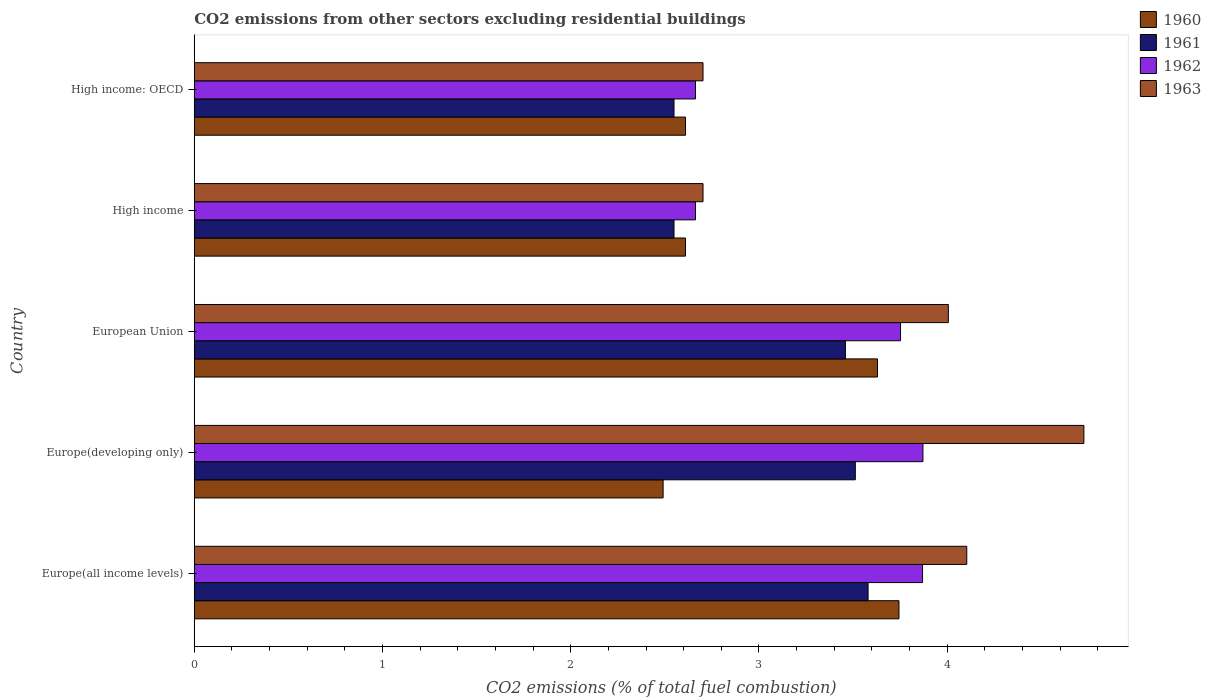Are the number of bars per tick equal to the number of legend labels?
Your answer should be compact. Yes. How many bars are there on the 2nd tick from the bottom?
Offer a terse response. 4. What is the label of the 5th group of bars from the top?
Your answer should be very brief. Europe(all income levels). In how many cases, is the number of bars for a given country not equal to the number of legend labels?
Keep it short and to the point. 0. What is the total CO2 emitted in 1963 in Europe(developing only)?
Your answer should be compact. 4.73. Across all countries, what is the maximum total CO2 emitted in 1960?
Ensure brevity in your answer.  3.74. Across all countries, what is the minimum total CO2 emitted in 1960?
Offer a terse response. 2.49. In which country was the total CO2 emitted in 1960 maximum?
Provide a succinct answer. Europe(all income levels). In which country was the total CO2 emitted in 1960 minimum?
Make the answer very short. Europe(developing only). What is the total total CO2 emitted in 1961 in the graph?
Give a very brief answer. 15.65. What is the difference between the total CO2 emitted in 1963 in European Union and that in High income: OECD?
Offer a terse response. 1.3. What is the difference between the total CO2 emitted in 1960 in High income and the total CO2 emitted in 1963 in High income: OECD?
Provide a succinct answer. -0.09. What is the average total CO2 emitted in 1961 per country?
Offer a terse response. 3.13. What is the difference between the total CO2 emitted in 1961 and total CO2 emitted in 1963 in European Union?
Provide a short and direct response. -0.55. In how many countries, is the total CO2 emitted in 1963 greater than 4.2 ?
Your answer should be compact. 1. What is the ratio of the total CO2 emitted in 1961 in Europe(developing only) to that in High income?
Ensure brevity in your answer.  1.38. What is the difference between the highest and the second highest total CO2 emitted in 1963?
Ensure brevity in your answer.  0.62. What is the difference between the highest and the lowest total CO2 emitted in 1962?
Your answer should be compact. 1.21. Is the sum of the total CO2 emitted in 1963 in Europe(all income levels) and High income greater than the maximum total CO2 emitted in 1960 across all countries?
Offer a very short reply. Yes. Is it the case that in every country, the sum of the total CO2 emitted in 1963 and total CO2 emitted in 1960 is greater than the sum of total CO2 emitted in 1961 and total CO2 emitted in 1962?
Ensure brevity in your answer.  No. What does the 3rd bar from the top in High income: OECD represents?
Keep it short and to the point. 1961. How many bars are there?
Provide a succinct answer. 20. How many countries are there in the graph?
Make the answer very short. 5. What is the difference between two consecutive major ticks on the X-axis?
Keep it short and to the point. 1. Does the graph contain any zero values?
Your response must be concise. No. Does the graph contain grids?
Provide a short and direct response. No. Where does the legend appear in the graph?
Provide a short and direct response. Top right. How many legend labels are there?
Give a very brief answer. 4. What is the title of the graph?
Your answer should be compact. CO2 emissions from other sectors excluding residential buildings. What is the label or title of the X-axis?
Offer a terse response. CO2 emissions (% of total fuel combustion). What is the label or title of the Y-axis?
Keep it short and to the point. Country. What is the CO2 emissions (% of total fuel combustion) in 1960 in Europe(all income levels)?
Ensure brevity in your answer.  3.74. What is the CO2 emissions (% of total fuel combustion) in 1961 in Europe(all income levels)?
Offer a very short reply. 3.58. What is the CO2 emissions (% of total fuel combustion) in 1962 in Europe(all income levels)?
Provide a short and direct response. 3.87. What is the CO2 emissions (% of total fuel combustion) of 1963 in Europe(all income levels)?
Your answer should be compact. 4.1. What is the CO2 emissions (% of total fuel combustion) of 1960 in Europe(developing only)?
Your answer should be very brief. 2.49. What is the CO2 emissions (% of total fuel combustion) in 1961 in Europe(developing only)?
Provide a succinct answer. 3.51. What is the CO2 emissions (% of total fuel combustion) of 1962 in Europe(developing only)?
Your answer should be very brief. 3.87. What is the CO2 emissions (% of total fuel combustion) in 1963 in Europe(developing only)?
Provide a succinct answer. 4.73. What is the CO2 emissions (% of total fuel combustion) of 1960 in European Union?
Keep it short and to the point. 3.63. What is the CO2 emissions (% of total fuel combustion) of 1961 in European Union?
Give a very brief answer. 3.46. What is the CO2 emissions (% of total fuel combustion) of 1962 in European Union?
Your answer should be very brief. 3.75. What is the CO2 emissions (% of total fuel combustion) in 1963 in European Union?
Make the answer very short. 4.01. What is the CO2 emissions (% of total fuel combustion) in 1960 in High income?
Your answer should be compact. 2.61. What is the CO2 emissions (% of total fuel combustion) in 1961 in High income?
Your response must be concise. 2.55. What is the CO2 emissions (% of total fuel combustion) in 1962 in High income?
Your answer should be compact. 2.66. What is the CO2 emissions (% of total fuel combustion) in 1963 in High income?
Provide a succinct answer. 2.7. What is the CO2 emissions (% of total fuel combustion) in 1960 in High income: OECD?
Your answer should be compact. 2.61. What is the CO2 emissions (% of total fuel combustion) of 1961 in High income: OECD?
Provide a short and direct response. 2.55. What is the CO2 emissions (% of total fuel combustion) in 1962 in High income: OECD?
Your answer should be compact. 2.66. What is the CO2 emissions (% of total fuel combustion) in 1963 in High income: OECD?
Offer a terse response. 2.7. Across all countries, what is the maximum CO2 emissions (% of total fuel combustion) of 1960?
Give a very brief answer. 3.74. Across all countries, what is the maximum CO2 emissions (% of total fuel combustion) of 1961?
Make the answer very short. 3.58. Across all countries, what is the maximum CO2 emissions (% of total fuel combustion) of 1962?
Your answer should be very brief. 3.87. Across all countries, what is the maximum CO2 emissions (% of total fuel combustion) of 1963?
Give a very brief answer. 4.73. Across all countries, what is the minimum CO2 emissions (% of total fuel combustion) in 1960?
Keep it short and to the point. 2.49. Across all countries, what is the minimum CO2 emissions (% of total fuel combustion) in 1961?
Ensure brevity in your answer.  2.55. Across all countries, what is the minimum CO2 emissions (% of total fuel combustion) in 1962?
Provide a short and direct response. 2.66. Across all countries, what is the minimum CO2 emissions (% of total fuel combustion) in 1963?
Ensure brevity in your answer.  2.7. What is the total CO2 emissions (% of total fuel combustion) of 1960 in the graph?
Provide a short and direct response. 15.08. What is the total CO2 emissions (% of total fuel combustion) of 1961 in the graph?
Ensure brevity in your answer.  15.65. What is the total CO2 emissions (% of total fuel combustion) in 1962 in the graph?
Your answer should be very brief. 16.82. What is the total CO2 emissions (% of total fuel combustion) of 1963 in the graph?
Make the answer very short. 18.24. What is the difference between the CO2 emissions (% of total fuel combustion) of 1960 in Europe(all income levels) and that in Europe(developing only)?
Make the answer very short. 1.25. What is the difference between the CO2 emissions (% of total fuel combustion) of 1961 in Europe(all income levels) and that in Europe(developing only)?
Your response must be concise. 0.07. What is the difference between the CO2 emissions (% of total fuel combustion) of 1962 in Europe(all income levels) and that in Europe(developing only)?
Provide a short and direct response. -0. What is the difference between the CO2 emissions (% of total fuel combustion) of 1963 in Europe(all income levels) and that in Europe(developing only)?
Your answer should be very brief. -0.62. What is the difference between the CO2 emissions (% of total fuel combustion) in 1960 in Europe(all income levels) and that in European Union?
Provide a short and direct response. 0.11. What is the difference between the CO2 emissions (% of total fuel combustion) in 1961 in Europe(all income levels) and that in European Union?
Your answer should be compact. 0.12. What is the difference between the CO2 emissions (% of total fuel combustion) of 1962 in Europe(all income levels) and that in European Union?
Offer a terse response. 0.12. What is the difference between the CO2 emissions (% of total fuel combustion) in 1963 in Europe(all income levels) and that in European Union?
Keep it short and to the point. 0.1. What is the difference between the CO2 emissions (% of total fuel combustion) in 1960 in Europe(all income levels) and that in High income?
Your response must be concise. 1.13. What is the difference between the CO2 emissions (% of total fuel combustion) in 1961 in Europe(all income levels) and that in High income?
Offer a very short reply. 1.03. What is the difference between the CO2 emissions (% of total fuel combustion) in 1962 in Europe(all income levels) and that in High income?
Offer a very short reply. 1.21. What is the difference between the CO2 emissions (% of total fuel combustion) in 1963 in Europe(all income levels) and that in High income?
Provide a short and direct response. 1.4. What is the difference between the CO2 emissions (% of total fuel combustion) of 1960 in Europe(all income levels) and that in High income: OECD?
Your answer should be compact. 1.13. What is the difference between the CO2 emissions (% of total fuel combustion) in 1961 in Europe(all income levels) and that in High income: OECD?
Offer a terse response. 1.03. What is the difference between the CO2 emissions (% of total fuel combustion) of 1962 in Europe(all income levels) and that in High income: OECD?
Offer a terse response. 1.21. What is the difference between the CO2 emissions (% of total fuel combustion) in 1963 in Europe(all income levels) and that in High income: OECD?
Your response must be concise. 1.4. What is the difference between the CO2 emissions (% of total fuel combustion) in 1960 in Europe(developing only) and that in European Union?
Your answer should be very brief. -1.14. What is the difference between the CO2 emissions (% of total fuel combustion) in 1961 in Europe(developing only) and that in European Union?
Provide a succinct answer. 0.05. What is the difference between the CO2 emissions (% of total fuel combustion) of 1962 in Europe(developing only) and that in European Union?
Provide a short and direct response. 0.12. What is the difference between the CO2 emissions (% of total fuel combustion) in 1963 in Europe(developing only) and that in European Union?
Your answer should be very brief. 0.72. What is the difference between the CO2 emissions (% of total fuel combustion) in 1960 in Europe(developing only) and that in High income?
Your response must be concise. -0.12. What is the difference between the CO2 emissions (% of total fuel combustion) of 1961 in Europe(developing only) and that in High income?
Ensure brevity in your answer.  0.96. What is the difference between the CO2 emissions (% of total fuel combustion) of 1962 in Europe(developing only) and that in High income?
Provide a short and direct response. 1.21. What is the difference between the CO2 emissions (% of total fuel combustion) in 1963 in Europe(developing only) and that in High income?
Your answer should be compact. 2.02. What is the difference between the CO2 emissions (% of total fuel combustion) of 1960 in Europe(developing only) and that in High income: OECD?
Provide a short and direct response. -0.12. What is the difference between the CO2 emissions (% of total fuel combustion) of 1961 in Europe(developing only) and that in High income: OECD?
Provide a short and direct response. 0.96. What is the difference between the CO2 emissions (% of total fuel combustion) of 1962 in Europe(developing only) and that in High income: OECD?
Offer a very short reply. 1.21. What is the difference between the CO2 emissions (% of total fuel combustion) of 1963 in Europe(developing only) and that in High income: OECD?
Make the answer very short. 2.02. What is the difference between the CO2 emissions (% of total fuel combustion) of 1961 in European Union and that in High income?
Ensure brevity in your answer.  0.91. What is the difference between the CO2 emissions (% of total fuel combustion) in 1962 in European Union and that in High income?
Keep it short and to the point. 1.09. What is the difference between the CO2 emissions (% of total fuel combustion) of 1963 in European Union and that in High income?
Make the answer very short. 1.3. What is the difference between the CO2 emissions (% of total fuel combustion) of 1960 in European Union and that in High income: OECD?
Offer a terse response. 1.02. What is the difference between the CO2 emissions (% of total fuel combustion) of 1961 in European Union and that in High income: OECD?
Ensure brevity in your answer.  0.91. What is the difference between the CO2 emissions (% of total fuel combustion) of 1962 in European Union and that in High income: OECD?
Your answer should be very brief. 1.09. What is the difference between the CO2 emissions (% of total fuel combustion) of 1963 in European Union and that in High income: OECD?
Provide a short and direct response. 1.3. What is the difference between the CO2 emissions (% of total fuel combustion) in 1961 in High income and that in High income: OECD?
Offer a terse response. 0. What is the difference between the CO2 emissions (% of total fuel combustion) of 1963 in High income and that in High income: OECD?
Provide a short and direct response. 0. What is the difference between the CO2 emissions (% of total fuel combustion) in 1960 in Europe(all income levels) and the CO2 emissions (% of total fuel combustion) in 1961 in Europe(developing only)?
Offer a terse response. 0.23. What is the difference between the CO2 emissions (% of total fuel combustion) in 1960 in Europe(all income levels) and the CO2 emissions (% of total fuel combustion) in 1962 in Europe(developing only)?
Your answer should be compact. -0.13. What is the difference between the CO2 emissions (% of total fuel combustion) of 1960 in Europe(all income levels) and the CO2 emissions (% of total fuel combustion) of 1963 in Europe(developing only)?
Give a very brief answer. -0.98. What is the difference between the CO2 emissions (% of total fuel combustion) of 1961 in Europe(all income levels) and the CO2 emissions (% of total fuel combustion) of 1962 in Europe(developing only)?
Keep it short and to the point. -0.29. What is the difference between the CO2 emissions (% of total fuel combustion) in 1961 in Europe(all income levels) and the CO2 emissions (% of total fuel combustion) in 1963 in Europe(developing only)?
Provide a short and direct response. -1.15. What is the difference between the CO2 emissions (% of total fuel combustion) of 1962 in Europe(all income levels) and the CO2 emissions (% of total fuel combustion) of 1963 in Europe(developing only)?
Your response must be concise. -0.86. What is the difference between the CO2 emissions (% of total fuel combustion) in 1960 in Europe(all income levels) and the CO2 emissions (% of total fuel combustion) in 1961 in European Union?
Your response must be concise. 0.28. What is the difference between the CO2 emissions (% of total fuel combustion) of 1960 in Europe(all income levels) and the CO2 emissions (% of total fuel combustion) of 1962 in European Union?
Keep it short and to the point. -0.01. What is the difference between the CO2 emissions (% of total fuel combustion) of 1960 in Europe(all income levels) and the CO2 emissions (% of total fuel combustion) of 1963 in European Union?
Your response must be concise. -0.26. What is the difference between the CO2 emissions (% of total fuel combustion) of 1961 in Europe(all income levels) and the CO2 emissions (% of total fuel combustion) of 1962 in European Union?
Your answer should be compact. -0.17. What is the difference between the CO2 emissions (% of total fuel combustion) of 1961 in Europe(all income levels) and the CO2 emissions (% of total fuel combustion) of 1963 in European Union?
Your response must be concise. -0.43. What is the difference between the CO2 emissions (% of total fuel combustion) in 1962 in Europe(all income levels) and the CO2 emissions (% of total fuel combustion) in 1963 in European Union?
Provide a succinct answer. -0.14. What is the difference between the CO2 emissions (% of total fuel combustion) in 1960 in Europe(all income levels) and the CO2 emissions (% of total fuel combustion) in 1961 in High income?
Your response must be concise. 1.2. What is the difference between the CO2 emissions (% of total fuel combustion) of 1960 in Europe(all income levels) and the CO2 emissions (% of total fuel combustion) of 1962 in High income?
Keep it short and to the point. 1.08. What is the difference between the CO2 emissions (% of total fuel combustion) in 1960 in Europe(all income levels) and the CO2 emissions (% of total fuel combustion) in 1963 in High income?
Give a very brief answer. 1.04. What is the difference between the CO2 emissions (% of total fuel combustion) of 1961 in Europe(all income levels) and the CO2 emissions (% of total fuel combustion) of 1962 in High income?
Your response must be concise. 0.92. What is the difference between the CO2 emissions (% of total fuel combustion) in 1961 in Europe(all income levels) and the CO2 emissions (% of total fuel combustion) in 1963 in High income?
Provide a short and direct response. 0.88. What is the difference between the CO2 emissions (% of total fuel combustion) of 1962 in Europe(all income levels) and the CO2 emissions (% of total fuel combustion) of 1963 in High income?
Ensure brevity in your answer.  1.17. What is the difference between the CO2 emissions (% of total fuel combustion) in 1960 in Europe(all income levels) and the CO2 emissions (% of total fuel combustion) in 1961 in High income: OECD?
Make the answer very short. 1.2. What is the difference between the CO2 emissions (% of total fuel combustion) in 1960 in Europe(all income levels) and the CO2 emissions (% of total fuel combustion) in 1962 in High income: OECD?
Offer a very short reply. 1.08. What is the difference between the CO2 emissions (% of total fuel combustion) of 1960 in Europe(all income levels) and the CO2 emissions (% of total fuel combustion) of 1963 in High income: OECD?
Provide a short and direct response. 1.04. What is the difference between the CO2 emissions (% of total fuel combustion) of 1961 in Europe(all income levels) and the CO2 emissions (% of total fuel combustion) of 1962 in High income: OECD?
Offer a terse response. 0.92. What is the difference between the CO2 emissions (% of total fuel combustion) of 1961 in Europe(all income levels) and the CO2 emissions (% of total fuel combustion) of 1963 in High income: OECD?
Your answer should be compact. 0.88. What is the difference between the CO2 emissions (% of total fuel combustion) of 1962 in Europe(all income levels) and the CO2 emissions (% of total fuel combustion) of 1963 in High income: OECD?
Your answer should be compact. 1.17. What is the difference between the CO2 emissions (% of total fuel combustion) of 1960 in Europe(developing only) and the CO2 emissions (% of total fuel combustion) of 1961 in European Union?
Ensure brevity in your answer.  -0.97. What is the difference between the CO2 emissions (% of total fuel combustion) in 1960 in Europe(developing only) and the CO2 emissions (% of total fuel combustion) in 1962 in European Union?
Your response must be concise. -1.26. What is the difference between the CO2 emissions (% of total fuel combustion) in 1960 in Europe(developing only) and the CO2 emissions (% of total fuel combustion) in 1963 in European Union?
Your answer should be compact. -1.52. What is the difference between the CO2 emissions (% of total fuel combustion) in 1961 in Europe(developing only) and the CO2 emissions (% of total fuel combustion) in 1962 in European Union?
Offer a terse response. -0.24. What is the difference between the CO2 emissions (% of total fuel combustion) of 1961 in Europe(developing only) and the CO2 emissions (% of total fuel combustion) of 1963 in European Union?
Your response must be concise. -0.49. What is the difference between the CO2 emissions (% of total fuel combustion) in 1962 in Europe(developing only) and the CO2 emissions (% of total fuel combustion) in 1963 in European Union?
Offer a terse response. -0.14. What is the difference between the CO2 emissions (% of total fuel combustion) of 1960 in Europe(developing only) and the CO2 emissions (% of total fuel combustion) of 1961 in High income?
Provide a short and direct response. -0.06. What is the difference between the CO2 emissions (% of total fuel combustion) in 1960 in Europe(developing only) and the CO2 emissions (% of total fuel combustion) in 1962 in High income?
Offer a very short reply. -0.17. What is the difference between the CO2 emissions (% of total fuel combustion) in 1960 in Europe(developing only) and the CO2 emissions (% of total fuel combustion) in 1963 in High income?
Your answer should be compact. -0.21. What is the difference between the CO2 emissions (% of total fuel combustion) in 1961 in Europe(developing only) and the CO2 emissions (% of total fuel combustion) in 1962 in High income?
Give a very brief answer. 0.85. What is the difference between the CO2 emissions (% of total fuel combustion) of 1961 in Europe(developing only) and the CO2 emissions (% of total fuel combustion) of 1963 in High income?
Make the answer very short. 0.81. What is the difference between the CO2 emissions (% of total fuel combustion) of 1962 in Europe(developing only) and the CO2 emissions (% of total fuel combustion) of 1963 in High income?
Your response must be concise. 1.17. What is the difference between the CO2 emissions (% of total fuel combustion) in 1960 in Europe(developing only) and the CO2 emissions (% of total fuel combustion) in 1961 in High income: OECD?
Keep it short and to the point. -0.06. What is the difference between the CO2 emissions (% of total fuel combustion) of 1960 in Europe(developing only) and the CO2 emissions (% of total fuel combustion) of 1962 in High income: OECD?
Make the answer very short. -0.17. What is the difference between the CO2 emissions (% of total fuel combustion) in 1960 in Europe(developing only) and the CO2 emissions (% of total fuel combustion) in 1963 in High income: OECD?
Your response must be concise. -0.21. What is the difference between the CO2 emissions (% of total fuel combustion) of 1961 in Europe(developing only) and the CO2 emissions (% of total fuel combustion) of 1962 in High income: OECD?
Offer a very short reply. 0.85. What is the difference between the CO2 emissions (% of total fuel combustion) in 1961 in Europe(developing only) and the CO2 emissions (% of total fuel combustion) in 1963 in High income: OECD?
Make the answer very short. 0.81. What is the difference between the CO2 emissions (% of total fuel combustion) of 1962 in Europe(developing only) and the CO2 emissions (% of total fuel combustion) of 1963 in High income: OECD?
Give a very brief answer. 1.17. What is the difference between the CO2 emissions (% of total fuel combustion) of 1960 in European Union and the CO2 emissions (% of total fuel combustion) of 1961 in High income?
Keep it short and to the point. 1.08. What is the difference between the CO2 emissions (% of total fuel combustion) in 1960 in European Union and the CO2 emissions (% of total fuel combustion) in 1963 in High income?
Keep it short and to the point. 0.93. What is the difference between the CO2 emissions (% of total fuel combustion) in 1961 in European Union and the CO2 emissions (% of total fuel combustion) in 1962 in High income?
Give a very brief answer. 0.8. What is the difference between the CO2 emissions (% of total fuel combustion) in 1961 in European Union and the CO2 emissions (% of total fuel combustion) in 1963 in High income?
Your response must be concise. 0.76. What is the difference between the CO2 emissions (% of total fuel combustion) in 1962 in European Union and the CO2 emissions (% of total fuel combustion) in 1963 in High income?
Provide a short and direct response. 1.05. What is the difference between the CO2 emissions (% of total fuel combustion) in 1960 in European Union and the CO2 emissions (% of total fuel combustion) in 1961 in High income: OECD?
Provide a succinct answer. 1.08. What is the difference between the CO2 emissions (% of total fuel combustion) of 1960 in European Union and the CO2 emissions (% of total fuel combustion) of 1963 in High income: OECD?
Keep it short and to the point. 0.93. What is the difference between the CO2 emissions (% of total fuel combustion) in 1961 in European Union and the CO2 emissions (% of total fuel combustion) in 1962 in High income: OECD?
Your answer should be very brief. 0.8. What is the difference between the CO2 emissions (% of total fuel combustion) of 1961 in European Union and the CO2 emissions (% of total fuel combustion) of 1963 in High income: OECD?
Offer a terse response. 0.76. What is the difference between the CO2 emissions (% of total fuel combustion) in 1962 in European Union and the CO2 emissions (% of total fuel combustion) in 1963 in High income: OECD?
Your answer should be very brief. 1.05. What is the difference between the CO2 emissions (% of total fuel combustion) of 1960 in High income and the CO2 emissions (% of total fuel combustion) of 1961 in High income: OECD?
Keep it short and to the point. 0.06. What is the difference between the CO2 emissions (% of total fuel combustion) in 1960 in High income and the CO2 emissions (% of total fuel combustion) in 1962 in High income: OECD?
Ensure brevity in your answer.  -0.05. What is the difference between the CO2 emissions (% of total fuel combustion) of 1960 in High income and the CO2 emissions (% of total fuel combustion) of 1963 in High income: OECD?
Offer a very short reply. -0.09. What is the difference between the CO2 emissions (% of total fuel combustion) in 1961 in High income and the CO2 emissions (% of total fuel combustion) in 1962 in High income: OECD?
Your answer should be very brief. -0.11. What is the difference between the CO2 emissions (% of total fuel combustion) in 1961 in High income and the CO2 emissions (% of total fuel combustion) in 1963 in High income: OECD?
Ensure brevity in your answer.  -0.15. What is the difference between the CO2 emissions (% of total fuel combustion) of 1962 in High income and the CO2 emissions (% of total fuel combustion) of 1963 in High income: OECD?
Keep it short and to the point. -0.04. What is the average CO2 emissions (% of total fuel combustion) in 1960 per country?
Your answer should be very brief. 3.02. What is the average CO2 emissions (% of total fuel combustion) in 1961 per country?
Ensure brevity in your answer.  3.13. What is the average CO2 emissions (% of total fuel combustion) in 1962 per country?
Offer a very short reply. 3.36. What is the average CO2 emissions (% of total fuel combustion) of 1963 per country?
Provide a short and direct response. 3.65. What is the difference between the CO2 emissions (% of total fuel combustion) of 1960 and CO2 emissions (% of total fuel combustion) of 1961 in Europe(all income levels)?
Give a very brief answer. 0.16. What is the difference between the CO2 emissions (% of total fuel combustion) of 1960 and CO2 emissions (% of total fuel combustion) of 1962 in Europe(all income levels)?
Offer a very short reply. -0.13. What is the difference between the CO2 emissions (% of total fuel combustion) of 1960 and CO2 emissions (% of total fuel combustion) of 1963 in Europe(all income levels)?
Your response must be concise. -0.36. What is the difference between the CO2 emissions (% of total fuel combustion) of 1961 and CO2 emissions (% of total fuel combustion) of 1962 in Europe(all income levels)?
Keep it short and to the point. -0.29. What is the difference between the CO2 emissions (% of total fuel combustion) in 1961 and CO2 emissions (% of total fuel combustion) in 1963 in Europe(all income levels)?
Your answer should be very brief. -0.52. What is the difference between the CO2 emissions (% of total fuel combustion) in 1962 and CO2 emissions (% of total fuel combustion) in 1963 in Europe(all income levels)?
Provide a short and direct response. -0.23. What is the difference between the CO2 emissions (% of total fuel combustion) in 1960 and CO2 emissions (% of total fuel combustion) in 1961 in Europe(developing only)?
Give a very brief answer. -1.02. What is the difference between the CO2 emissions (% of total fuel combustion) in 1960 and CO2 emissions (% of total fuel combustion) in 1962 in Europe(developing only)?
Provide a succinct answer. -1.38. What is the difference between the CO2 emissions (% of total fuel combustion) in 1960 and CO2 emissions (% of total fuel combustion) in 1963 in Europe(developing only)?
Your answer should be very brief. -2.24. What is the difference between the CO2 emissions (% of total fuel combustion) in 1961 and CO2 emissions (% of total fuel combustion) in 1962 in Europe(developing only)?
Ensure brevity in your answer.  -0.36. What is the difference between the CO2 emissions (% of total fuel combustion) of 1961 and CO2 emissions (% of total fuel combustion) of 1963 in Europe(developing only)?
Ensure brevity in your answer.  -1.21. What is the difference between the CO2 emissions (% of total fuel combustion) of 1962 and CO2 emissions (% of total fuel combustion) of 1963 in Europe(developing only)?
Provide a short and direct response. -0.85. What is the difference between the CO2 emissions (% of total fuel combustion) in 1960 and CO2 emissions (% of total fuel combustion) in 1961 in European Union?
Your response must be concise. 0.17. What is the difference between the CO2 emissions (% of total fuel combustion) in 1960 and CO2 emissions (% of total fuel combustion) in 1962 in European Union?
Give a very brief answer. -0.12. What is the difference between the CO2 emissions (% of total fuel combustion) of 1960 and CO2 emissions (% of total fuel combustion) of 1963 in European Union?
Your answer should be compact. -0.38. What is the difference between the CO2 emissions (% of total fuel combustion) in 1961 and CO2 emissions (% of total fuel combustion) in 1962 in European Union?
Give a very brief answer. -0.29. What is the difference between the CO2 emissions (% of total fuel combustion) in 1961 and CO2 emissions (% of total fuel combustion) in 1963 in European Union?
Offer a terse response. -0.55. What is the difference between the CO2 emissions (% of total fuel combustion) in 1962 and CO2 emissions (% of total fuel combustion) in 1963 in European Union?
Ensure brevity in your answer.  -0.25. What is the difference between the CO2 emissions (% of total fuel combustion) in 1960 and CO2 emissions (% of total fuel combustion) in 1961 in High income?
Your response must be concise. 0.06. What is the difference between the CO2 emissions (% of total fuel combustion) in 1960 and CO2 emissions (% of total fuel combustion) in 1962 in High income?
Your response must be concise. -0.05. What is the difference between the CO2 emissions (% of total fuel combustion) of 1960 and CO2 emissions (% of total fuel combustion) of 1963 in High income?
Your answer should be very brief. -0.09. What is the difference between the CO2 emissions (% of total fuel combustion) of 1961 and CO2 emissions (% of total fuel combustion) of 1962 in High income?
Keep it short and to the point. -0.11. What is the difference between the CO2 emissions (% of total fuel combustion) of 1961 and CO2 emissions (% of total fuel combustion) of 1963 in High income?
Offer a terse response. -0.15. What is the difference between the CO2 emissions (% of total fuel combustion) in 1962 and CO2 emissions (% of total fuel combustion) in 1963 in High income?
Provide a succinct answer. -0.04. What is the difference between the CO2 emissions (% of total fuel combustion) of 1960 and CO2 emissions (% of total fuel combustion) of 1961 in High income: OECD?
Offer a terse response. 0.06. What is the difference between the CO2 emissions (% of total fuel combustion) in 1960 and CO2 emissions (% of total fuel combustion) in 1962 in High income: OECD?
Ensure brevity in your answer.  -0.05. What is the difference between the CO2 emissions (% of total fuel combustion) in 1960 and CO2 emissions (% of total fuel combustion) in 1963 in High income: OECD?
Ensure brevity in your answer.  -0.09. What is the difference between the CO2 emissions (% of total fuel combustion) of 1961 and CO2 emissions (% of total fuel combustion) of 1962 in High income: OECD?
Make the answer very short. -0.11. What is the difference between the CO2 emissions (% of total fuel combustion) of 1961 and CO2 emissions (% of total fuel combustion) of 1963 in High income: OECD?
Your answer should be compact. -0.15. What is the difference between the CO2 emissions (% of total fuel combustion) in 1962 and CO2 emissions (% of total fuel combustion) in 1963 in High income: OECD?
Make the answer very short. -0.04. What is the ratio of the CO2 emissions (% of total fuel combustion) of 1960 in Europe(all income levels) to that in Europe(developing only)?
Provide a short and direct response. 1.5. What is the ratio of the CO2 emissions (% of total fuel combustion) in 1961 in Europe(all income levels) to that in Europe(developing only)?
Your answer should be very brief. 1.02. What is the ratio of the CO2 emissions (% of total fuel combustion) of 1963 in Europe(all income levels) to that in Europe(developing only)?
Keep it short and to the point. 0.87. What is the ratio of the CO2 emissions (% of total fuel combustion) in 1960 in Europe(all income levels) to that in European Union?
Your response must be concise. 1.03. What is the ratio of the CO2 emissions (% of total fuel combustion) in 1961 in Europe(all income levels) to that in European Union?
Keep it short and to the point. 1.03. What is the ratio of the CO2 emissions (% of total fuel combustion) in 1962 in Europe(all income levels) to that in European Union?
Provide a short and direct response. 1.03. What is the ratio of the CO2 emissions (% of total fuel combustion) of 1963 in Europe(all income levels) to that in European Union?
Offer a very short reply. 1.02. What is the ratio of the CO2 emissions (% of total fuel combustion) in 1960 in Europe(all income levels) to that in High income?
Provide a short and direct response. 1.43. What is the ratio of the CO2 emissions (% of total fuel combustion) in 1961 in Europe(all income levels) to that in High income?
Offer a terse response. 1.4. What is the ratio of the CO2 emissions (% of total fuel combustion) of 1962 in Europe(all income levels) to that in High income?
Offer a terse response. 1.45. What is the ratio of the CO2 emissions (% of total fuel combustion) in 1963 in Europe(all income levels) to that in High income?
Keep it short and to the point. 1.52. What is the ratio of the CO2 emissions (% of total fuel combustion) of 1960 in Europe(all income levels) to that in High income: OECD?
Give a very brief answer. 1.43. What is the ratio of the CO2 emissions (% of total fuel combustion) of 1961 in Europe(all income levels) to that in High income: OECD?
Provide a short and direct response. 1.4. What is the ratio of the CO2 emissions (% of total fuel combustion) in 1962 in Europe(all income levels) to that in High income: OECD?
Your answer should be very brief. 1.45. What is the ratio of the CO2 emissions (% of total fuel combustion) in 1963 in Europe(all income levels) to that in High income: OECD?
Offer a very short reply. 1.52. What is the ratio of the CO2 emissions (% of total fuel combustion) of 1960 in Europe(developing only) to that in European Union?
Your response must be concise. 0.69. What is the ratio of the CO2 emissions (% of total fuel combustion) in 1961 in Europe(developing only) to that in European Union?
Give a very brief answer. 1.02. What is the ratio of the CO2 emissions (% of total fuel combustion) in 1962 in Europe(developing only) to that in European Union?
Give a very brief answer. 1.03. What is the ratio of the CO2 emissions (% of total fuel combustion) in 1963 in Europe(developing only) to that in European Union?
Give a very brief answer. 1.18. What is the ratio of the CO2 emissions (% of total fuel combustion) of 1960 in Europe(developing only) to that in High income?
Keep it short and to the point. 0.95. What is the ratio of the CO2 emissions (% of total fuel combustion) in 1961 in Europe(developing only) to that in High income?
Offer a very short reply. 1.38. What is the ratio of the CO2 emissions (% of total fuel combustion) of 1962 in Europe(developing only) to that in High income?
Offer a very short reply. 1.45. What is the ratio of the CO2 emissions (% of total fuel combustion) in 1963 in Europe(developing only) to that in High income?
Keep it short and to the point. 1.75. What is the ratio of the CO2 emissions (% of total fuel combustion) of 1960 in Europe(developing only) to that in High income: OECD?
Keep it short and to the point. 0.95. What is the ratio of the CO2 emissions (% of total fuel combustion) of 1961 in Europe(developing only) to that in High income: OECD?
Your response must be concise. 1.38. What is the ratio of the CO2 emissions (% of total fuel combustion) of 1962 in Europe(developing only) to that in High income: OECD?
Offer a very short reply. 1.45. What is the ratio of the CO2 emissions (% of total fuel combustion) of 1963 in Europe(developing only) to that in High income: OECD?
Offer a very short reply. 1.75. What is the ratio of the CO2 emissions (% of total fuel combustion) of 1960 in European Union to that in High income?
Ensure brevity in your answer.  1.39. What is the ratio of the CO2 emissions (% of total fuel combustion) of 1961 in European Union to that in High income?
Provide a succinct answer. 1.36. What is the ratio of the CO2 emissions (% of total fuel combustion) in 1962 in European Union to that in High income?
Make the answer very short. 1.41. What is the ratio of the CO2 emissions (% of total fuel combustion) of 1963 in European Union to that in High income?
Provide a short and direct response. 1.48. What is the ratio of the CO2 emissions (% of total fuel combustion) in 1960 in European Union to that in High income: OECD?
Offer a terse response. 1.39. What is the ratio of the CO2 emissions (% of total fuel combustion) of 1961 in European Union to that in High income: OECD?
Provide a short and direct response. 1.36. What is the ratio of the CO2 emissions (% of total fuel combustion) of 1962 in European Union to that in High income: OECD?
Ensure brevity in your answer.  1.41. What is the ratio of the CO2 emissions (% of total fuel combustion) of 1963 in European Union to that in High income: OECD?
Provide a succinct answer. 1.48. What is the ratio of the CO2 emissions (% of total fuel combustion) in 1961 in High income to that in High income: OECD?
Offer a terse response. 1. What is the ratio of the CO2 emissions (% of total fuel combustion) of 1962 in High income to that in High income: OECD?
Provide a short and direct response. 1. What is the difference between the highest and the second highest CO2 emissions (% of total fuel combustion) of 1960?
Your answer should be very brief. 0.11. What is the difference between the highest and the second highest CO2 emissions (% of total fuel combustion) in 1961?
Ensure brevity in your answer.  0.07. What is the difference between the highest and the second highest CO2 emissions (% of total fuel combustion) of 1962?
Make the answer very short. 0. What is the difference between the highest and the second highest CO2 emissions (% of total fuel combustion) of 1963?
Ensure brevity in your answer.  0.62. What is the difference between the highest and the lowest CO2 emissions (% of total fuel combustion) of 1960?
Provide a short and direct response. 1.25. What is the difference between the highest and the lowest CO2 emissions (% of total fuel combustion) of 1961?
Provide a short and direct response. 1.03. What is the difference between the highest and the lowest CO2 emissions (% of total fuel combustion) of 1962?
Provide a succinct answer. 1.21. What is the difference between the highest and the lowest CO2 emissions (% of total fuel combustion) in 1963?
Your answer should be very brief. 2.02. 